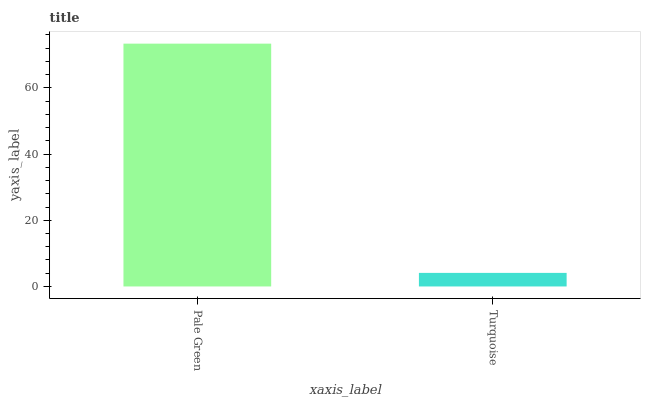Is Turquoise the minimum?
Answer yes or no. Yes. Is Pale Green the maximum?
Answer yes or no. Yes. Is Turquoise the maximum?
Answer yes or no. No. Is Pale Green greater than Turquoise?
Answer yes or no. Yes. Is Turquoise less than Pale Green?
Answer yes or no. Yes. Is Turquoise greater than Pale Green?
Answer yes or no. No. Is Pale Green less than Turquoise?
Answer yes or no. No. Is Pale Green the high median?
Answer yes or no. Yes. Is Turquoise the low median?
Answer yes or no. Yes. Is Turquoise the high median?
Answer yes or no. No. Is Pale Green the low median?
Answer yes or no. No. 